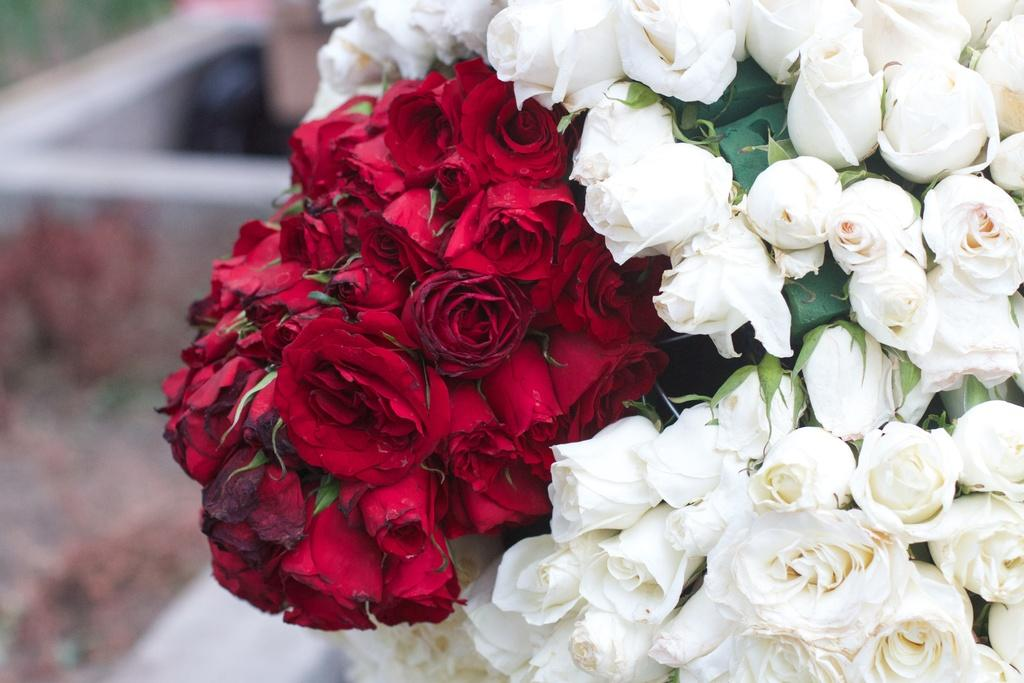What type of flowers are in the bouquet in the image? There is a bouquet of red and white roses in the image. Where is the bouquet located? The bouquet is kept on a wall. What type of vegetation can be seen in the image? There is grass visible in the top left corner of the image. What type of medical advice can be heard from the doctor in the image? There is no doctor present in the image, so no medical advice can be heard. Can you describe the prison cell in the image? There is no prison cell present in the image. What type of animal is grazing in the grass in the image? There is no animal present in the image, so it cannot be determined what type of animal might be grazing in the grass. 